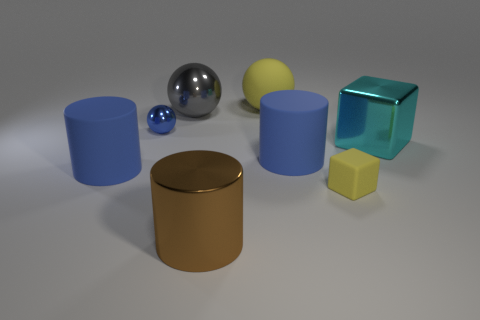Add 2 yellow cubes. How many objects exist? 10 Subtract all blocks. How many objects are left? 6 Subtract 0 red cylinders. How many objects are left? 8 Subtract all small purple matte cylinders. Subtract all big yellow spheres. How many objects are left? 7 Add 3 gray metallic balls. How many gray metallic balls are left? 4 Add 3 small shiny spheres. How many small shiny spheres exist? 4 